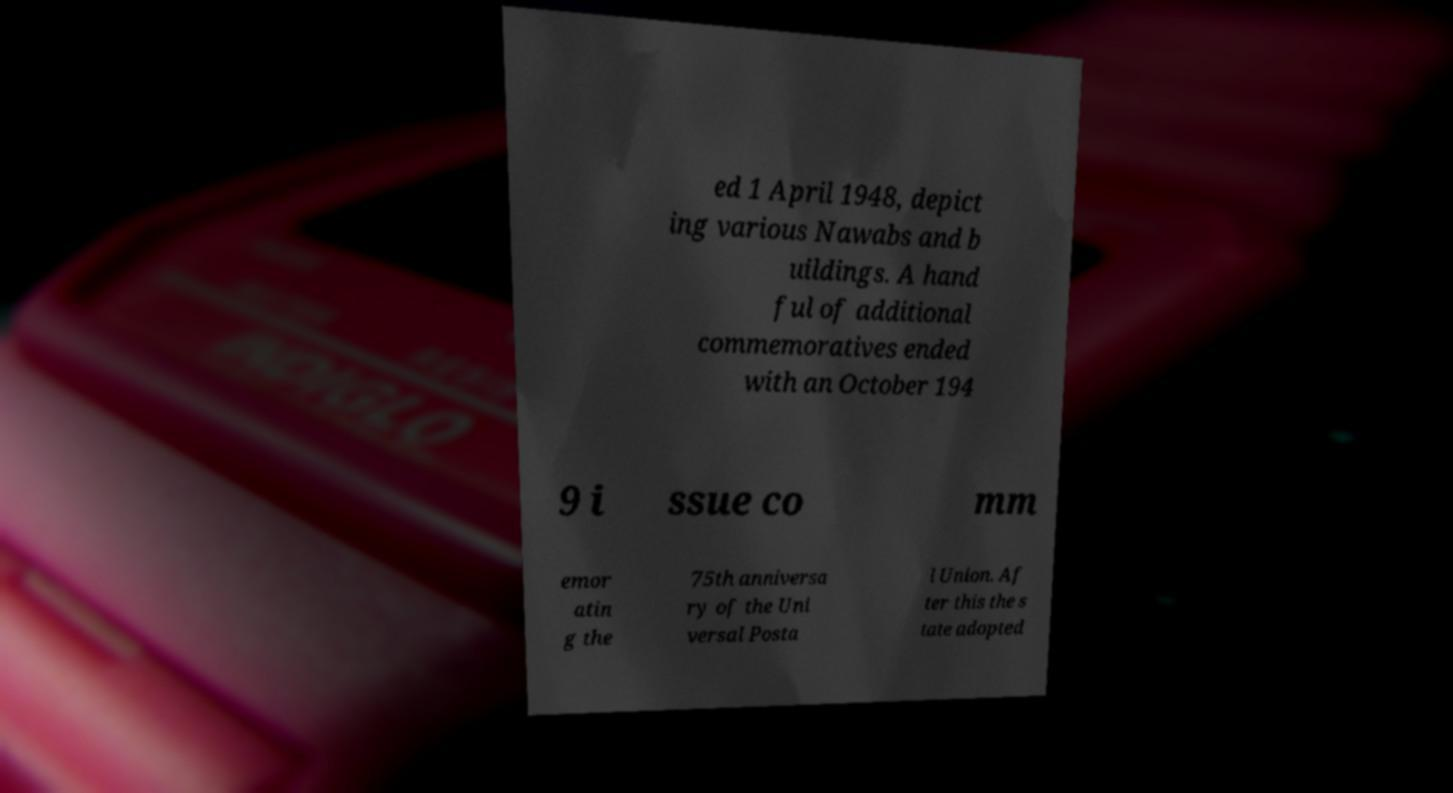For documentation purposes, I need the text within this image transcribed. Could you provide that? ed 1 April 1948, depict ing various Nawabs and b uildings. A hand ful of additional commemoratives ended with an October 194 9 i ssue co mm emor atin g the 75th anniversa ry of the Uni versal Posta l Union. Af ter this the s tate adopted 